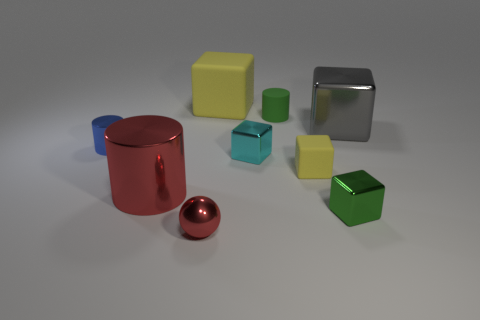Can you tell me the difference in textures among the objects in the image? Certainly! The objects in the image exhibit varying textures. The red cylinder and the silver cube reflect light smoothly, indicating a metallic and polished surface. In contrast, the yellow and green cubes display a matte finish, suggesting a non-reflective, perhaps plastic-like material. 